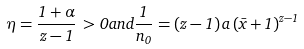<formula> <loc_0><loc_0><loc_500><loc_500>\eta = \frac { 1 + \alpha } { z - 1 } \, > 0 a n d \frac { 1 } { n _ { 0 } } = ( z - 1 ) \, a \, ( \bar { x } + 1 ) ^ { z - 1 }</formula> 